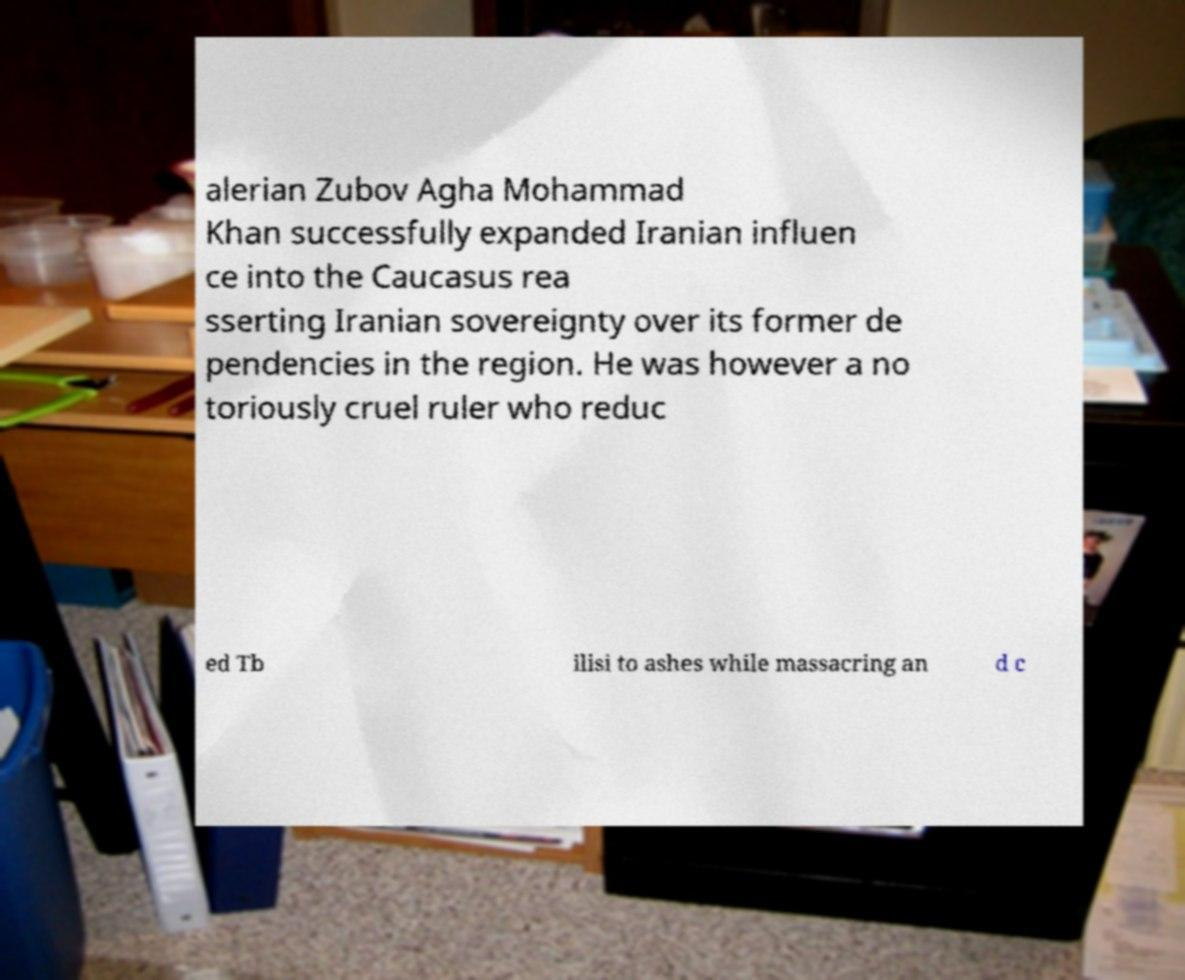Can you read and provide the text displayed in the image?This photo seems to have some interesting text. Can you extract and type it out for me? alerian Zubov Agha Mohammad Khan successfully expanded Iranian influen ce into the Caucasus rea sserting Iranian sovereignty over its former de pendencies in the region. He was however a no toriously cruel ruler who reduc ed Tb ilisi to ashes while massacring an d c 